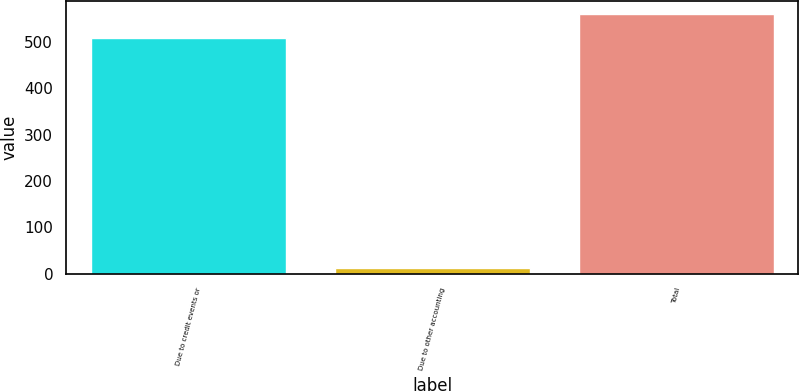Convert chart. <chart><loc_0><loc_0><loc_500><loc_500><bar_chart><fcel>Due to credit events or<fcel>Due to other accounting<fcel>Total<nl><fcel>508<fcel>12<fcel>558.8<nl></chart> 